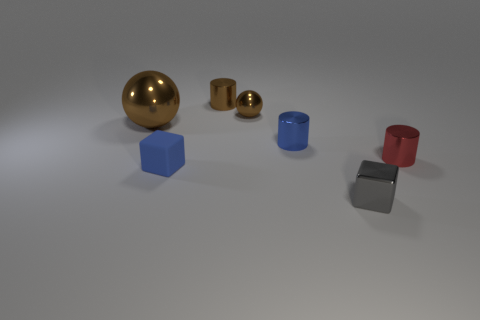Add 2 big purple cubes. How many objects exist? 9 Subtract all cubes. How many objects are left? 5 Subtract all brown spheres. Subtract all blue cubes. How many objects are left? 4 Add 6 blue metal cylinders. How many blue metal cylinders are left? 7 Add 6 brown cylinders. How many brown cylinders exist? 7 Subtract 2 brown balls. How many objects are left? 5 